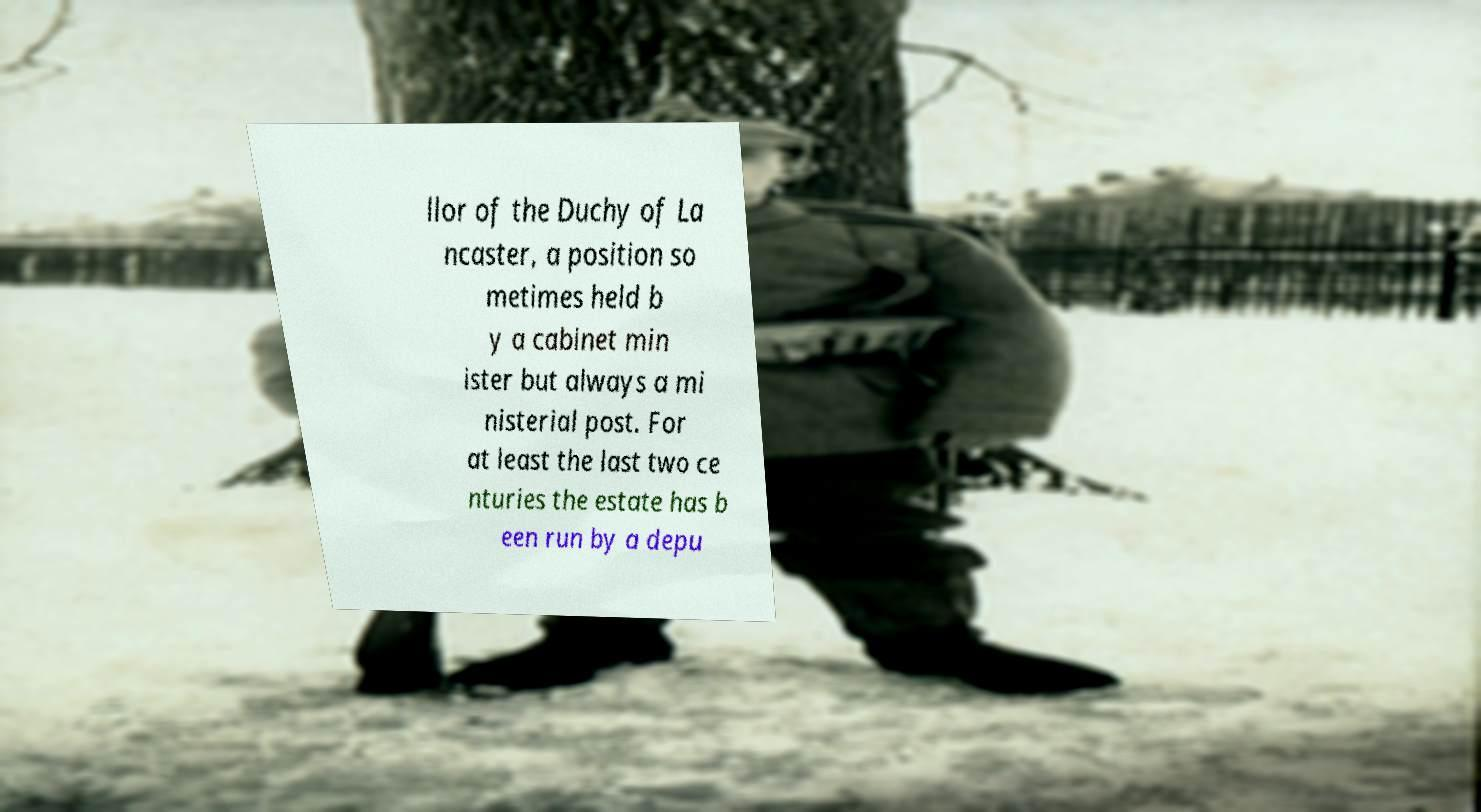For documentation purposes, I need the text within this image transcribed. Could you provide that? llor of the Duchy of La ncaster, a position so metimes held b y a cabinet min ister but always a mi nisterial post. For at least the last two ce nturies the estate has b een run by a depu 